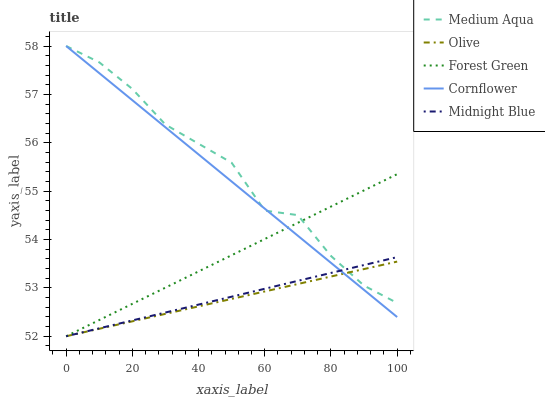Does Olive have the minimum area under the curve?
Answer yes or no. Yes. Does Medium Aqua have the maximum area under the curve?
Answer yes or no. Yes. Does Cornflower have the minimum area under the curve?
Answer yes or no. No. Does Cornflower have the maximum area under the curve?
Answer yes or no. No. Is Olive the smoothest?
Answer yes or no. Yes. Is Medium Aqua the roughest?
Answer yes or no. Yes. Is Cornflower the smoothest?
Answer yes or no. No. Is Cornflower the roughest?
Answer yes or no. No. Does Cornflower have the lowest value?
Answer yes or no. No. Does Medium Aqua have the highest value?
Answer yes or no. Yes. Does Forest Green have the highest value?
Answer yes or no. No. Does Forest Green intersect Medium Aqua?
Answer yes or no. Yes. Is Forest Green less than Medium Aqua?
Answer yes or no. No. Is Forest Green greater than Medium Aqua?
Answer yes or no. No. 